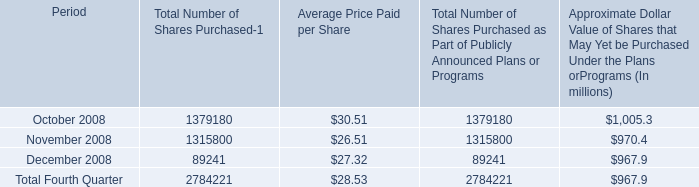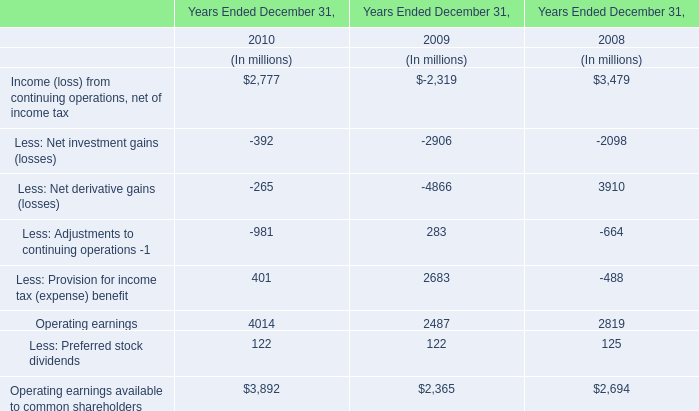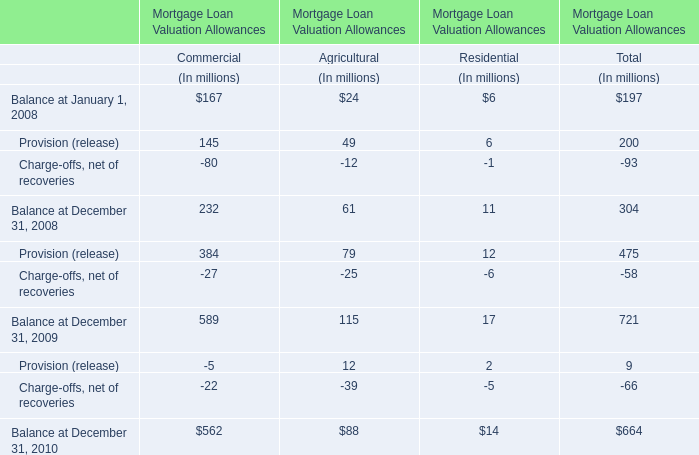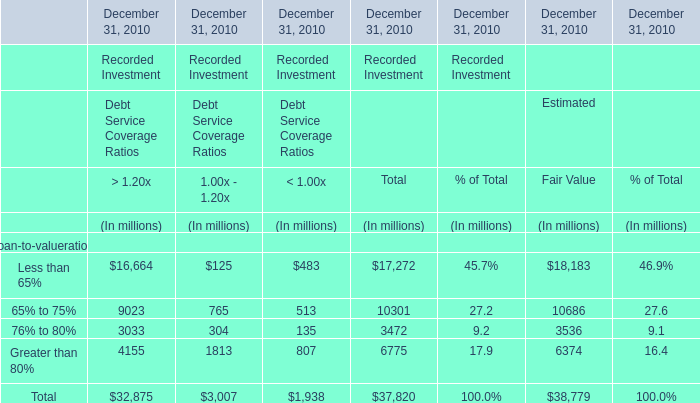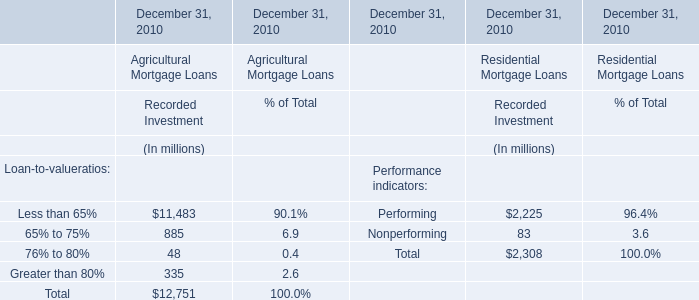What was the total amount of elements for Estimated in 2010? (in million) 
Answer: 38779. 